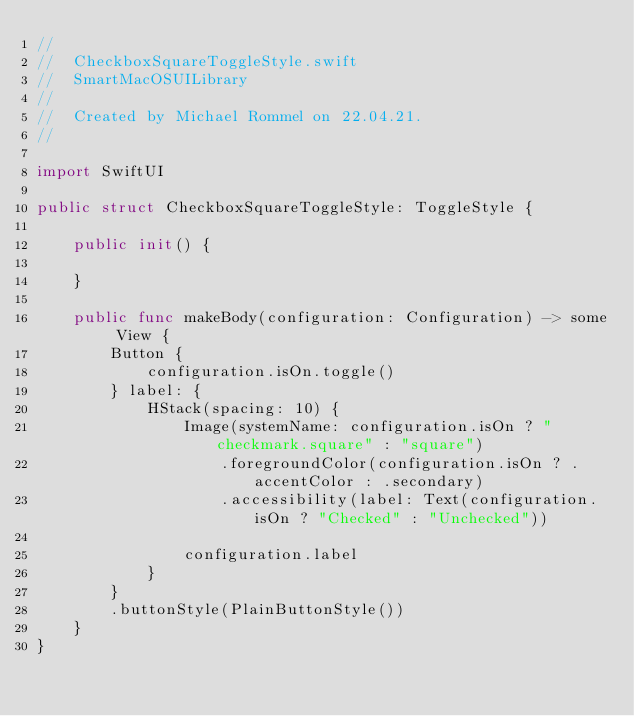<code> <loc_0><loc_0><loc_500><loc_500><_Swift_>//
//  CheckboxSquareToggleStyle.swift
//  SmartMacOSUILibrary
//
//  Created by Michael Rommel on 22.04.21.
//

import SwiftUI

public struct CheckboxSquareToggleStyle: ToggleStyle {

    public init() {

    }

    public func makeBody(configuration: Configuration) -> some View {
        Button {
            configuration.isOn.toggle()
        } label: {
            HStack(spacing: 10) {
                Image(systemName: configuration.isOn ? "checkmark.square" : "square")
                    .foregroundColor(configuration.isOn ? .accentColor : .secondary)
                    .accessibility(label: Text(configuration.isOn ? "Checked" : "Unchecked"))

                configuration.label
            }
        }
        .buttonStyle(PlainButtonStyle())
    }
}
</code> 